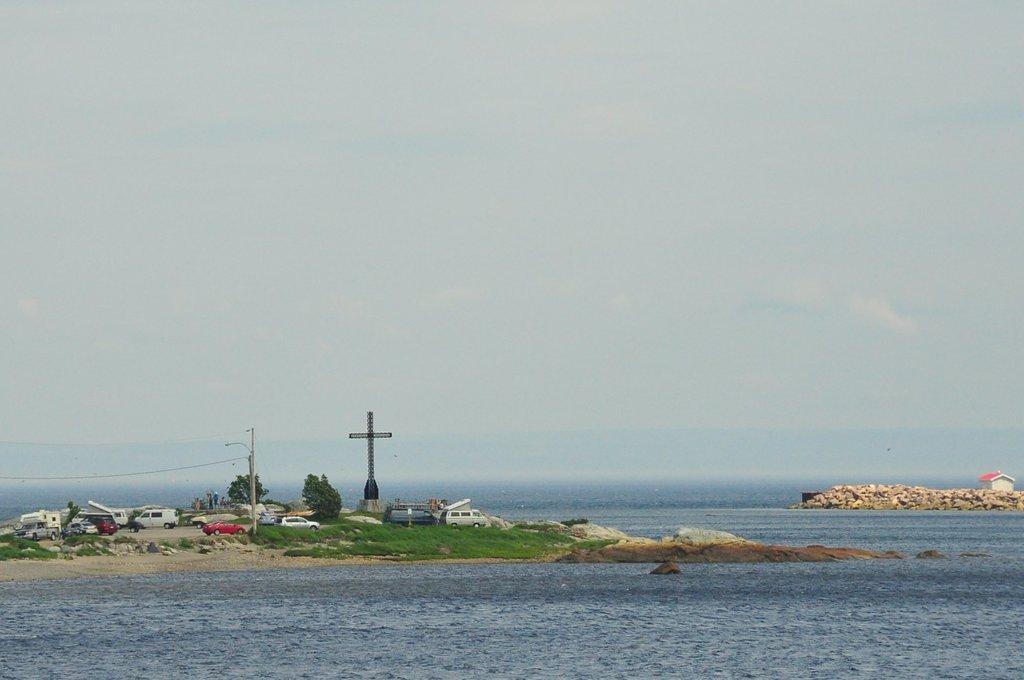In one or two sentences, can you explain what this image depicts? In this image, we can see vehicles, trees, a pole, tower and we can see a shed and there are rocks. At the top, there is sky and at the bottom, there is water. 